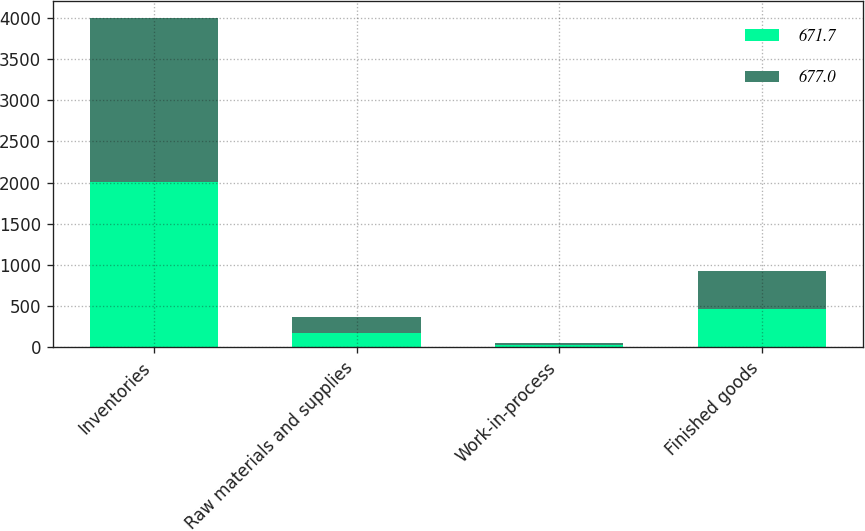<chart> <loc_0><loc_0><loc_500><loc_500><stacked_bar_chart><ecel><fcel>Inventories<fcel>Raw materials and supplies<fcel>Work-in-process<fcel>Finished goods<nl><fcel>671.7<fcel>2002<fcel>176.6<fcel>30.1<fcel>465<nl><fcel>677<fcel>2001<fcel>188<fcel>27.9<fcel>461.1<nl></chart> 